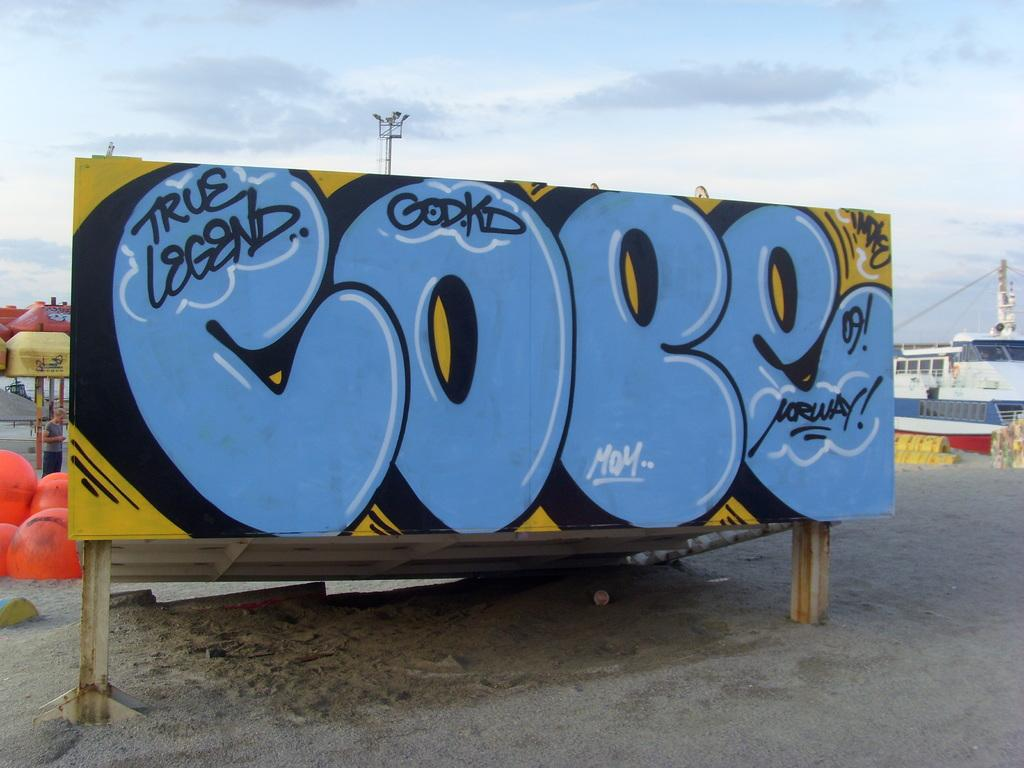Provide a one-sentence caption for the provided image. Large billboard that read COPE in graffiti on a beach. 